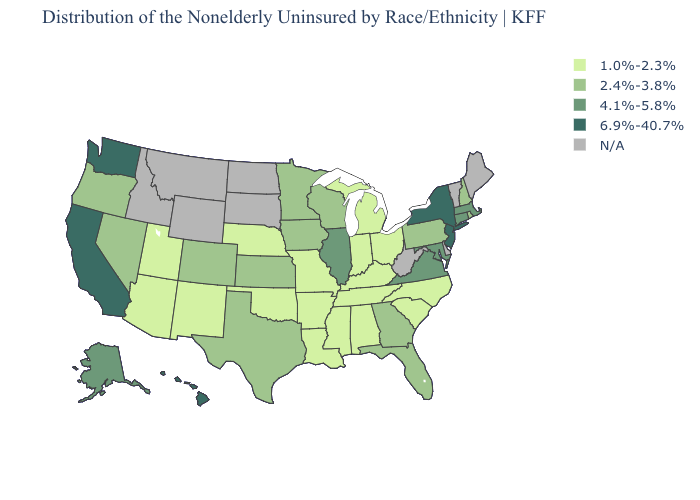What is the lowest value in the South?
Keep it brief. 1.0%-2.3%. Name the states that have a value in the range 4.1%-5.8%?
Be succinct. Alaska, Connecticut, Illinois, Maryland, Massachusetts, Virginia. Name the states that have a value in the range 2.4%-3.8%?
Be succinct. Colorado, Florida, Georgia, Iowa, Kansas, Minnesota, Nevada, New Hampshire, Oregon, Pennsylvania, Rhode Island, Texas, Wisconsin. Which states have the lowest value in the MidWest?
Answer briefly. Indiana, Michigan, Missouri, Nebraska, Ohio. Which states hav the highest value in the South?
Quick response, please. Maryland, Virginia. What is the highest value in the USA?
Give a very brief answer. 6.9%-40.7%. What is the value of Alabama?
Answer briefly. 1.0%-2.3%. What is the value of Nevada?
Be succinct. 2.4%-3.8%. What is the lowest value in states that border Nevada?
Be succinct. 1.0%-2.3%. Which states have the lowest value in the USA?
Keep it brief. Alabama, Arizona, Arkansas, Indiana, Kentucky, Louisiana, Michigan, Mississippi, Missouri, Nebraska, New Mexico, North Carolina, Ohio, Oklahoma, South Carolina, Tennessee, Utah. Name the states that have a value in the range 4.1%-5.8%?
Keep it brief. Alaska, Connecticut, Illinois, Maryland, Massachusetts, Virginia. Which states hav the highest value in the MidWest?
Be succinct. Illinois. What is the lowest value in the Northeast?
Keep it brief. 2.4%-3.8%. Name the states that have a value in the range N/A?
Answer briefly. Delaware, Idaho, Maine, Montana, North Dakota, South Dakota, Vermont, West Virginia, Wyoming. 